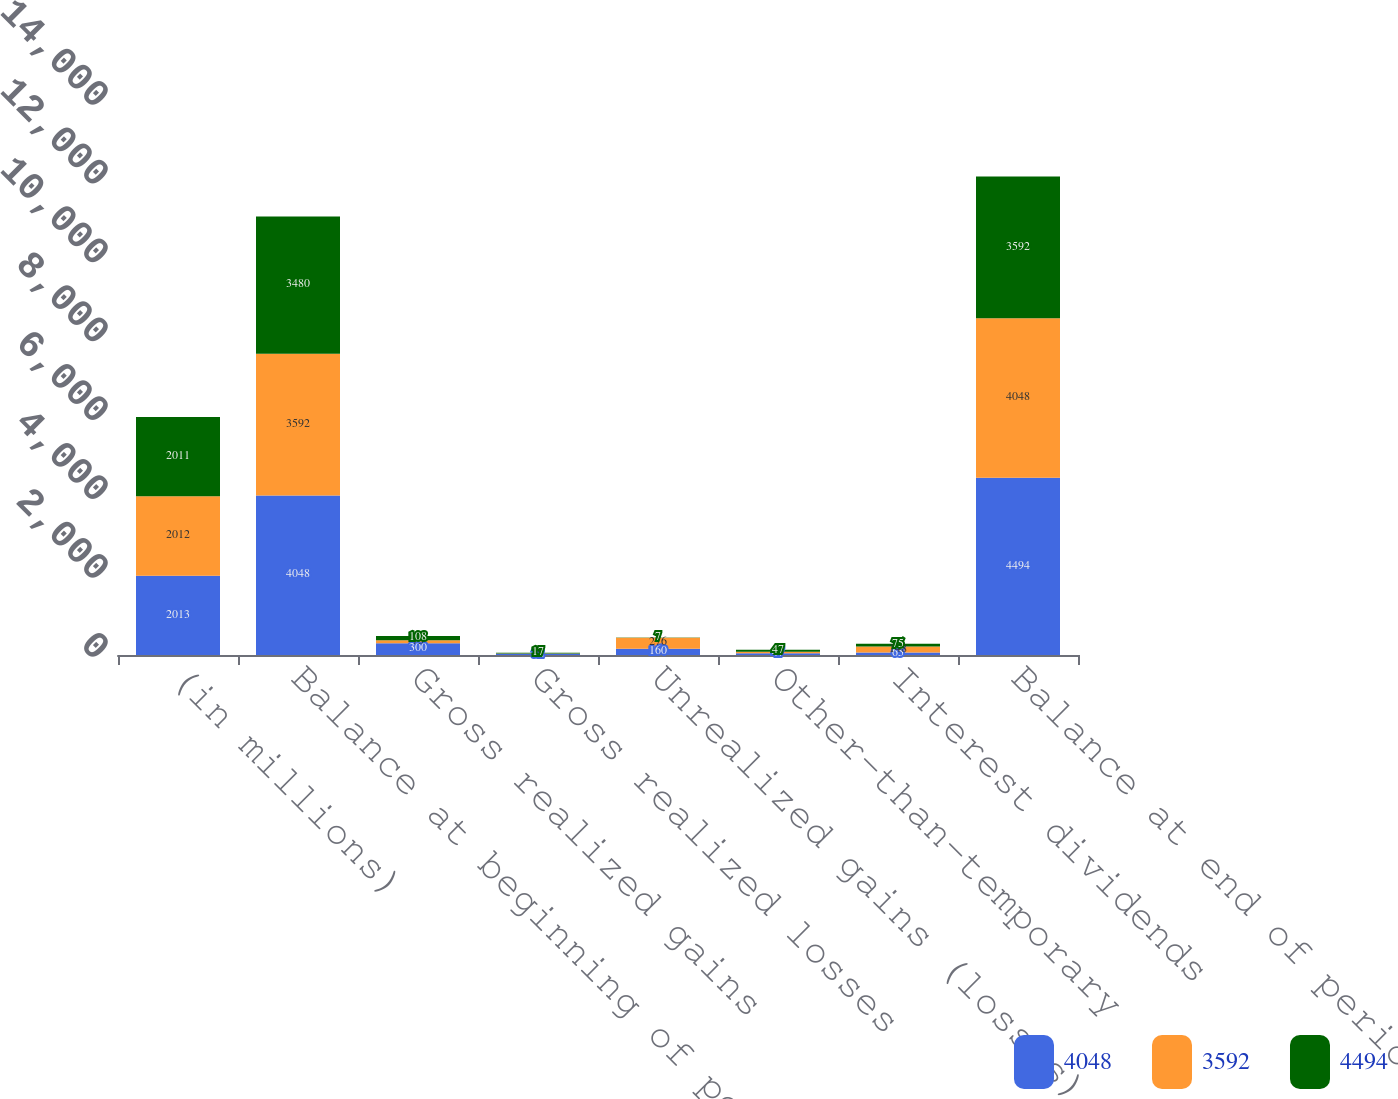Convert chart to OTSL. <chart><loc_0><loc_0><loc_500><loc_500><stacked_bar_chart><ecel><fcel>(in millions)<fcel>Balance at beginning of period<fcel>Gross realized gains<fcel>Gross realized losses<fcel>Unrealized gains (losses) net<fcel>Other-than-temporary<fcel>Interest dividends<fcel>Balance at end of period<nl><fcel>4048<fcel>2013<fcel>4048<fcel>300<fcel>32<fcel>160<fcel>47<fcel>65<fcel>4494<nl><fcel>3592<fcel>2012<fcel>3592<fcel>73<fcel>5<fcel>276<fcel>36<fcel>148<fcel>4048<nl><fcel>4494<fcel>2011<fcel>3480<fcel>108<fcel>17<fcel>7<fcel>47<fcel>75<fcel>3592<nl></chart> 